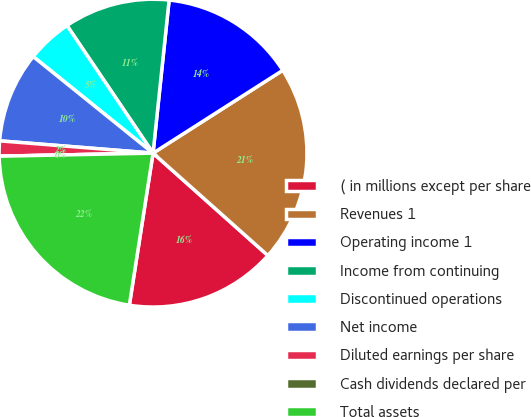Convert chart to OTSL. <chart><loc_0><loc_0><loc_500><loc_500><pie_chart><fcel>( in millions except per share<fcel>Revenues 1<fcel>Operating income 1<fcel>Income from continuing<fcel>Discontinued operations<fcel>Net income<fcel>Diluted earnings per share<fcel>Cash dividends declared per<fcel>Total assets<nl><fcel>15.87%<fcel>20.63%<fcel>14.29%<fcel>11.11%<fcel>4.76%<fcel>9.52%<fcel>1.59%<fcel>0.0%<fcel>22.22%<nl></chart> 